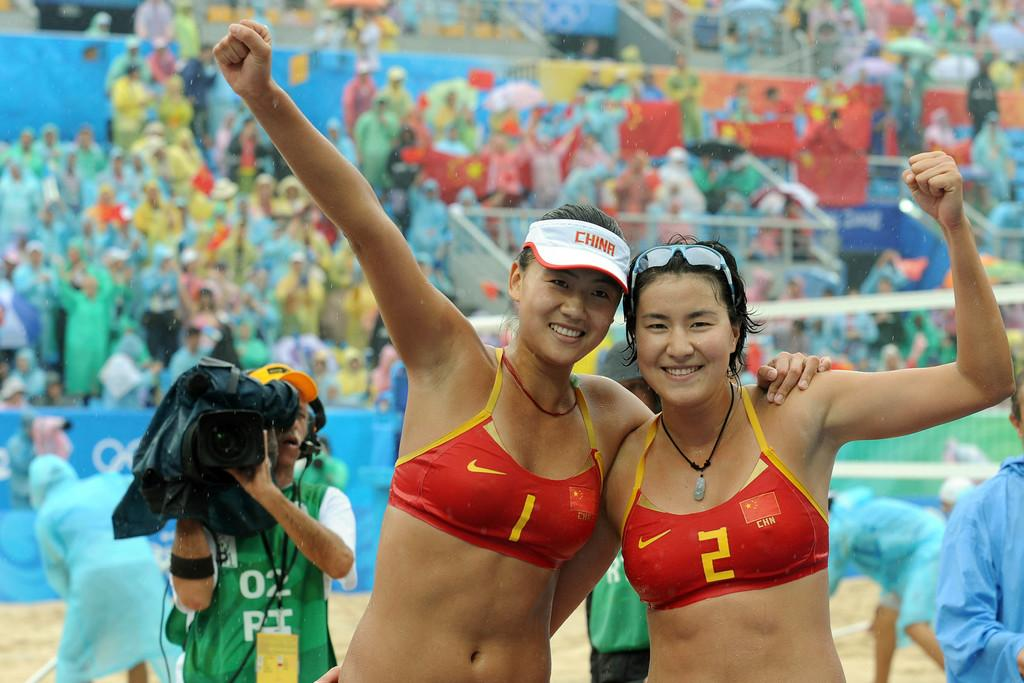<image>
Render a clear and concise summary of the photo. Player 1 and 2 on a Chinese beach volley ball team are being filmed as they pose for a picture. 